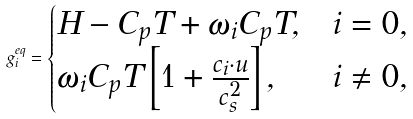Convert formula to latex. <formula><loc_0><loc_0><loc_500><loc_500>g ^ { e q } _ { i } = \begin{cases} H - C _ { p } T + \omega _ { i } C _ { p } T , & i = 0 , \\ \omega _ { i } C _ { p } T \left [ 1 + \frac { c _ { i } \cdot u } { c ^ { 2 } _ { s } } \right ] , & i \neq 0 , \end{cases}</formula> 